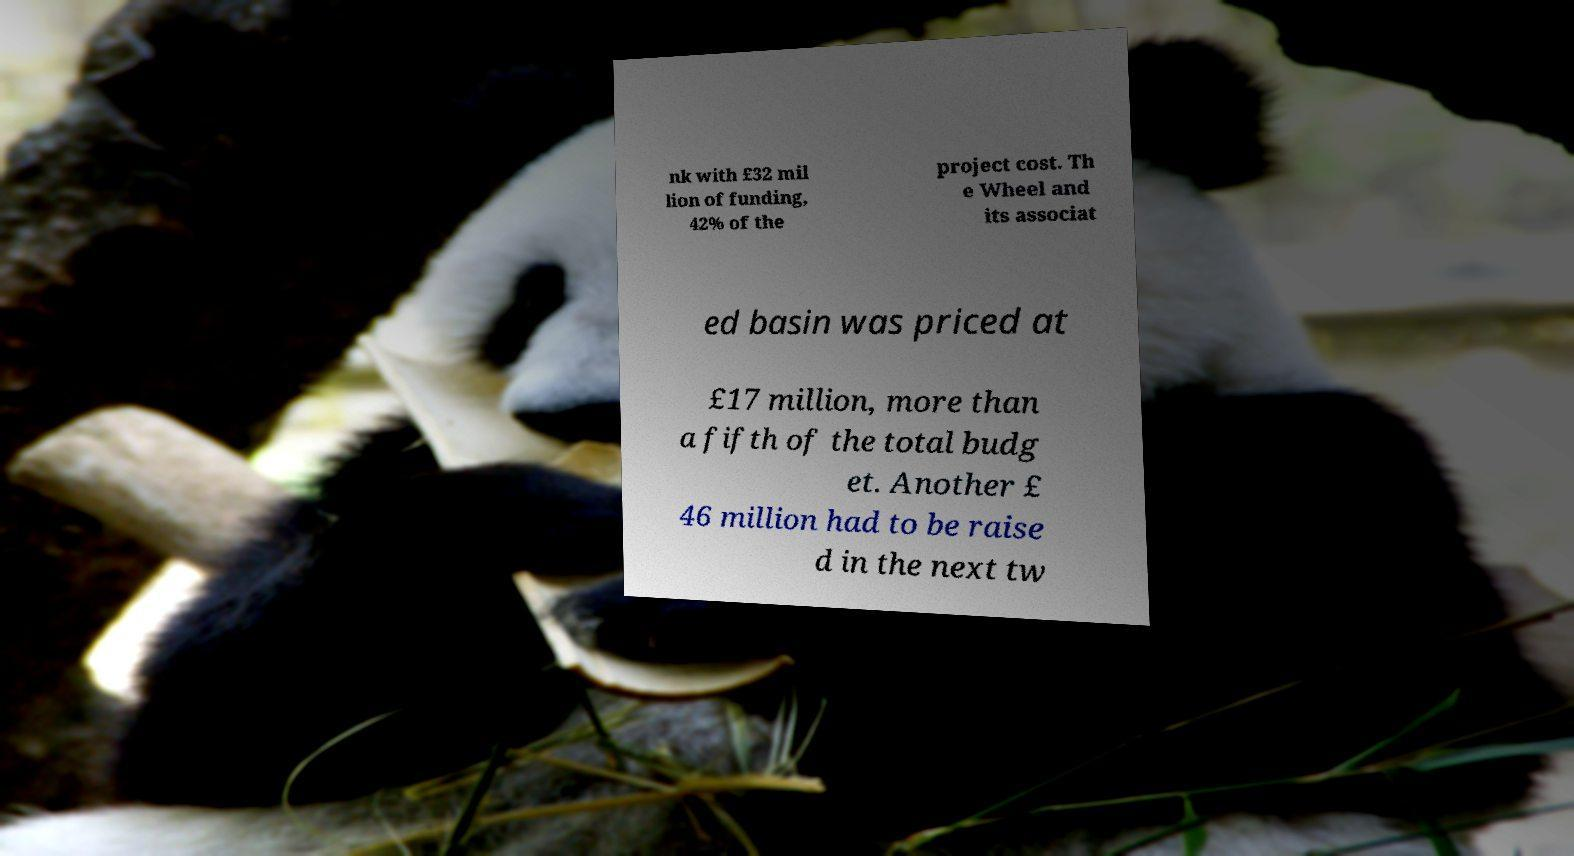Please read and relay the text visible in this image. What does it say? nk with £32 mil lion of funding, 42% of the project cost. Th e Wheel and its associat ed basin was priced at £17 million, more than a fifth of the total budg et. Another £ 46 million had to be raise d in the next tw 